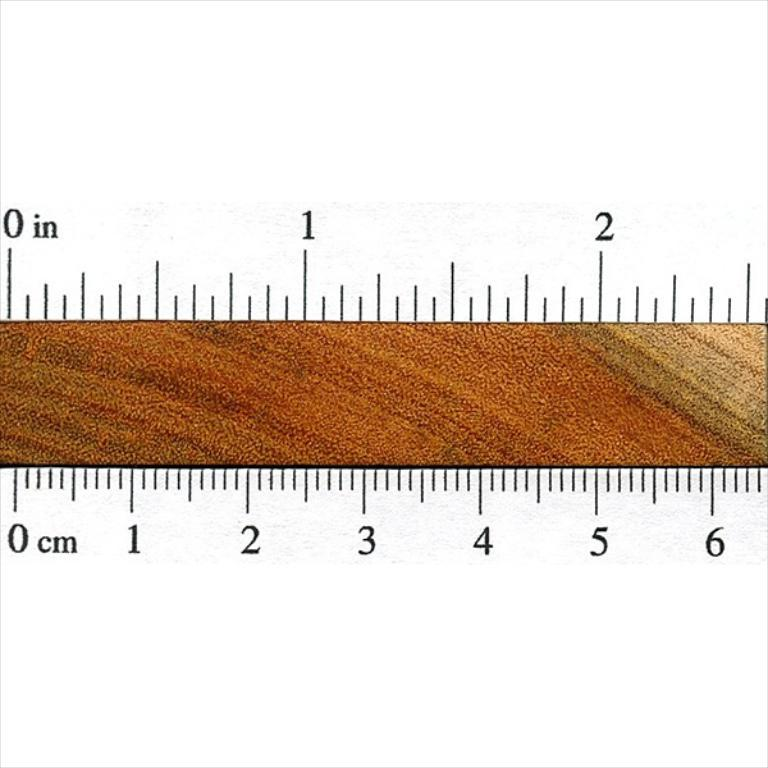<image>
Write a terse but informative summary of the picture. A measuring device showing the numbers 0 through 6 in cm on the bottom and numbers 0 through 2 in on the top. 